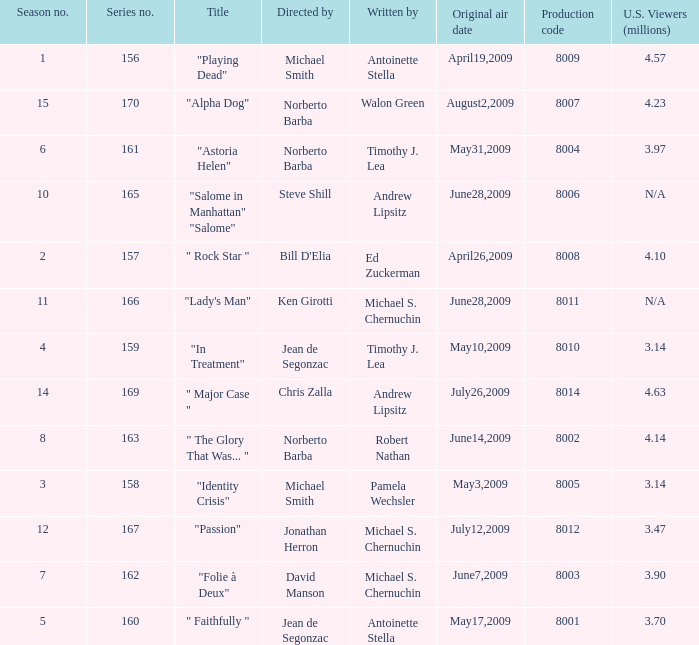Which is the biggest production code? 8014.0. 